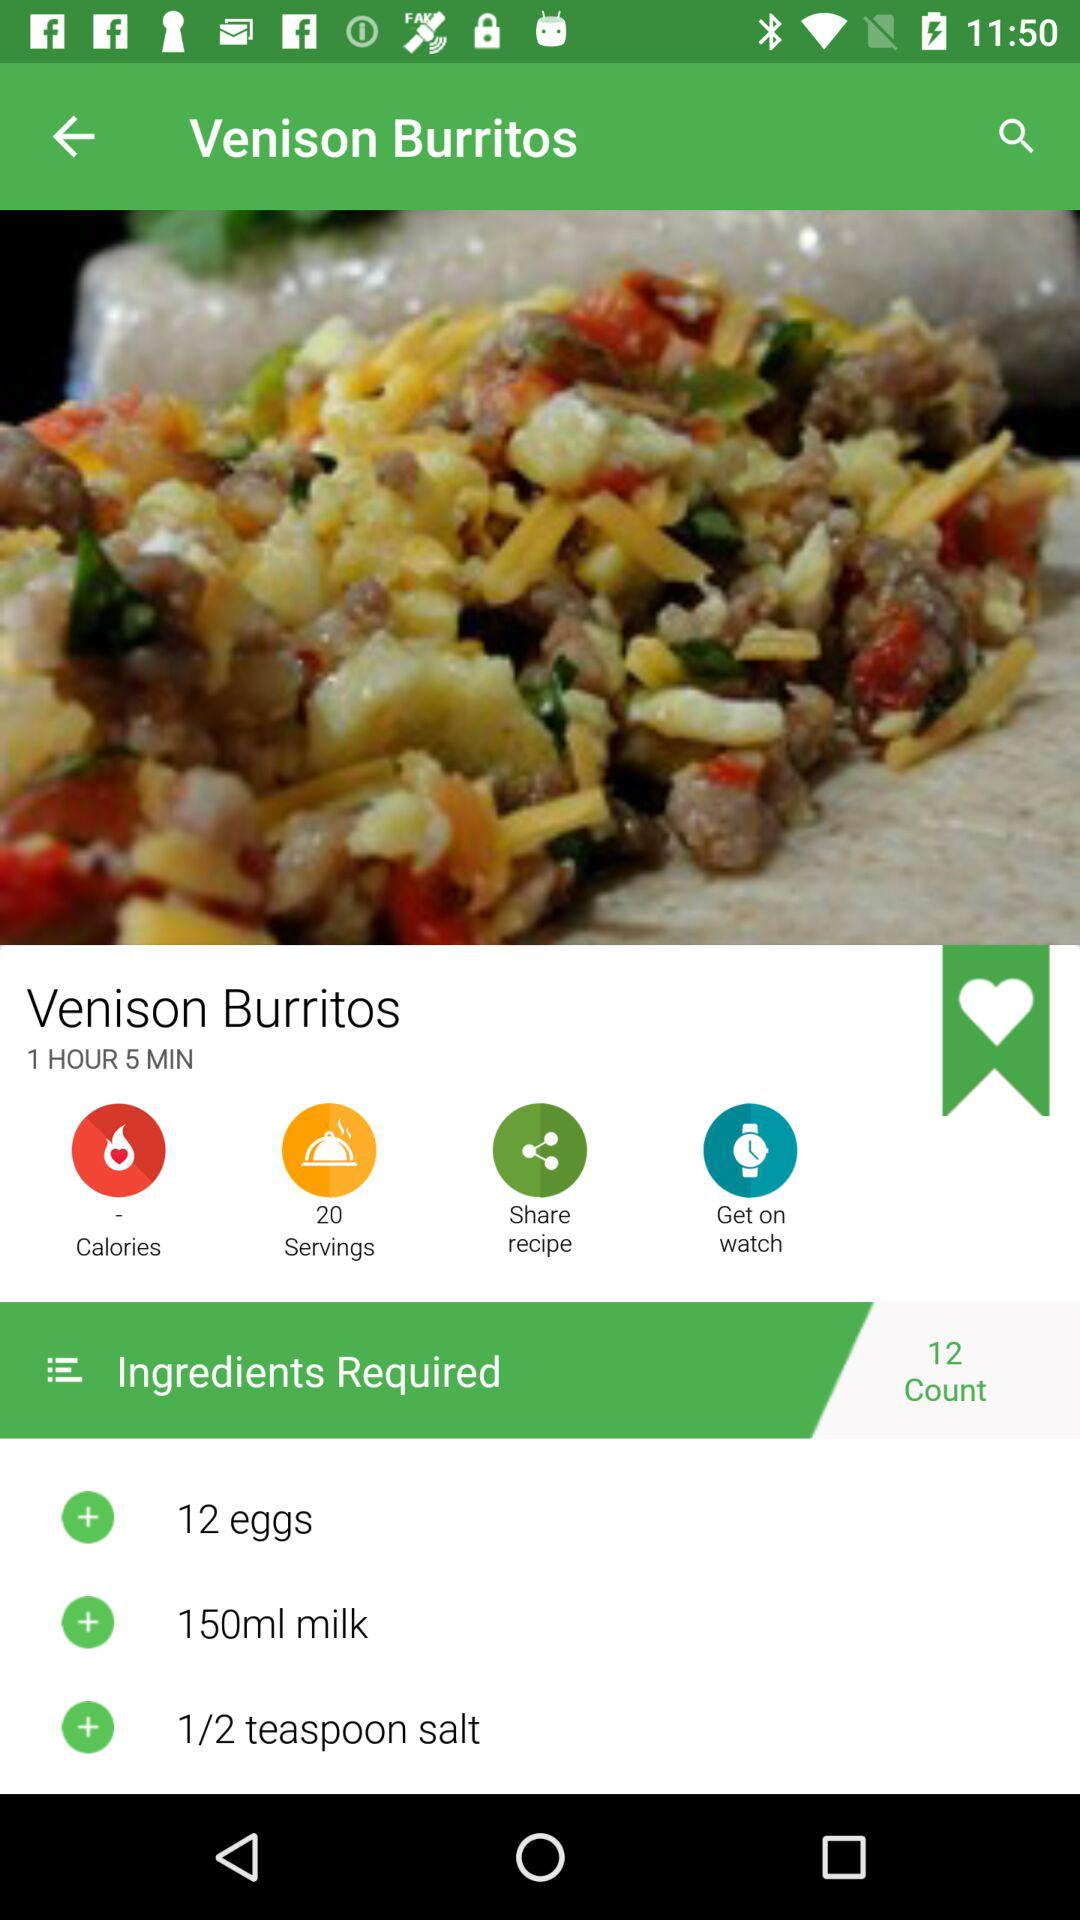How many servings does this recipe make?
Answer the question using a single word or phrase. 20 